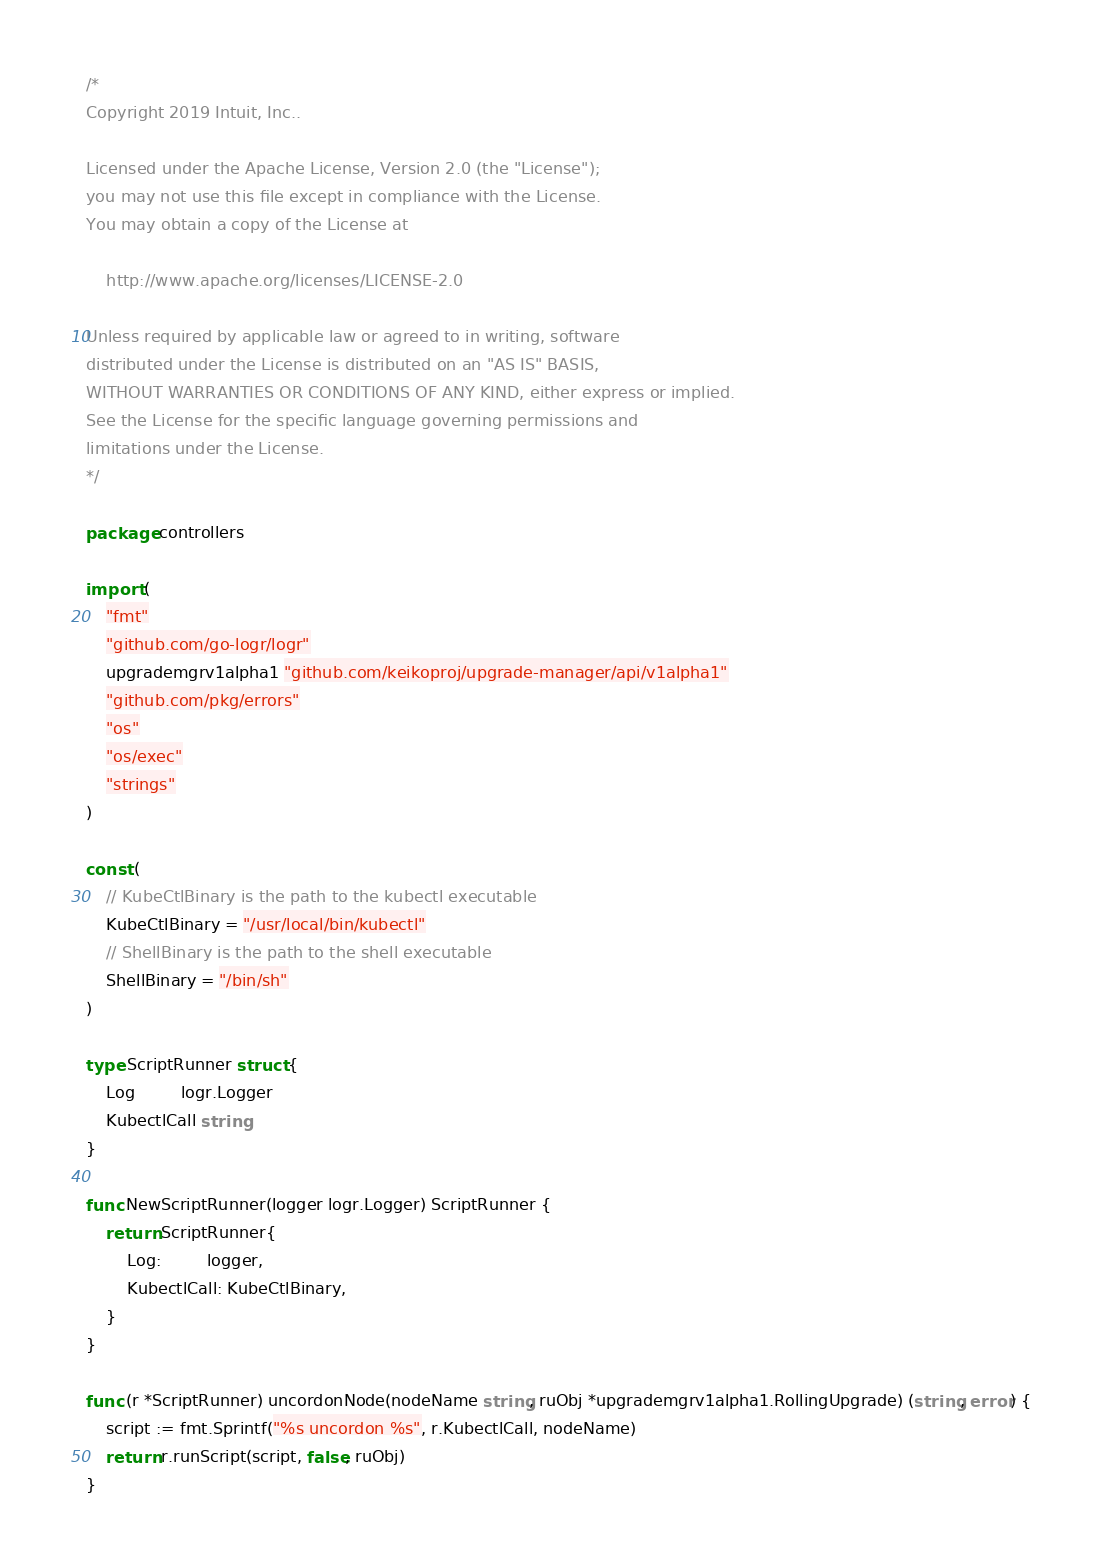Convert code to text. <code><loc_0><loc_0><loc_500><loc_500><_Go_>/*
Copyright 2019 Intuit, Inc..

Licensed under the Apache License, Version 2.0 (the "License");
you may not use this file except in compliance with the License.
You may obtain a copy of the License at

    http://www.apache.org/licenses/LICENSE-2.0

Unless required by applicable law or agreed to in writing, software
distributed under the License is distributed on an "AS IS" BASIS,
WITHOUT WARRANTIES OR CONDITIONS OF ANY KIND, either express or implied.
See the License for the specific language governing permissions and
limitations under the License.
*/

package controllers

import (
	"fmt"
	"github.com/go-logr/logr"
	upgrademgrv1alpha1 "github.com/keikoproj/upgrade-manager/api/v1alpha1"
	"github.com/pkg/errors"
	"os"
	"os/exec"
	"strings"
)

const (
	// KubeCtlBinary is the path to the kubectl executable
	KubeCtlBinary = "/usr/local/bin/kubectl"
	// ShellBinary is the path to the shell executable
	ShellBinary = "/bin/sh"
)

type ScriptRunner struct {
	Log         logr.Logger
	KubectlCall string
}

func NewScriptRunner(logger logr.Logger) ScriptRunner {
	return ScriptRunner{
		Log:         logger,
		KubectlCall: KubeCtlBinary,
	}
}

func (r *ScriptRunner) uncordonNode(nodeName string, ruObj *upgrademgrv1alpha1.RollingUpgrade) (string, error) {
	script := fmt.Sprintf("%s uncordon %s", r.KubectlCall, nodeName)
	return r.runScript(script, false, ruObj)
}
</code> 